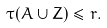<formula> <loc_0><loc_0><loc_500><loc_500>\tau ( A \cup Z ) \leqslant r .</formula> 